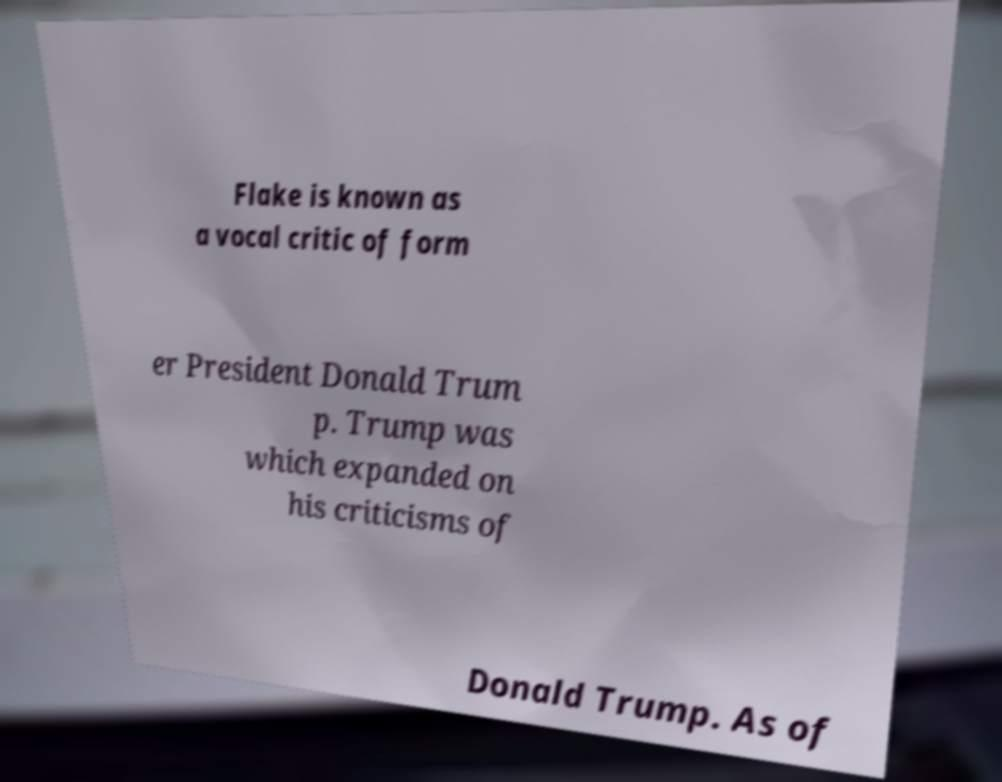What messages or text are displayed in this image? I need them in a readable, typed format. Flake is known as a vocal critic of form er President Donald Trum p. Trump was which expanded on his criticisms of Donald Trump. As of 